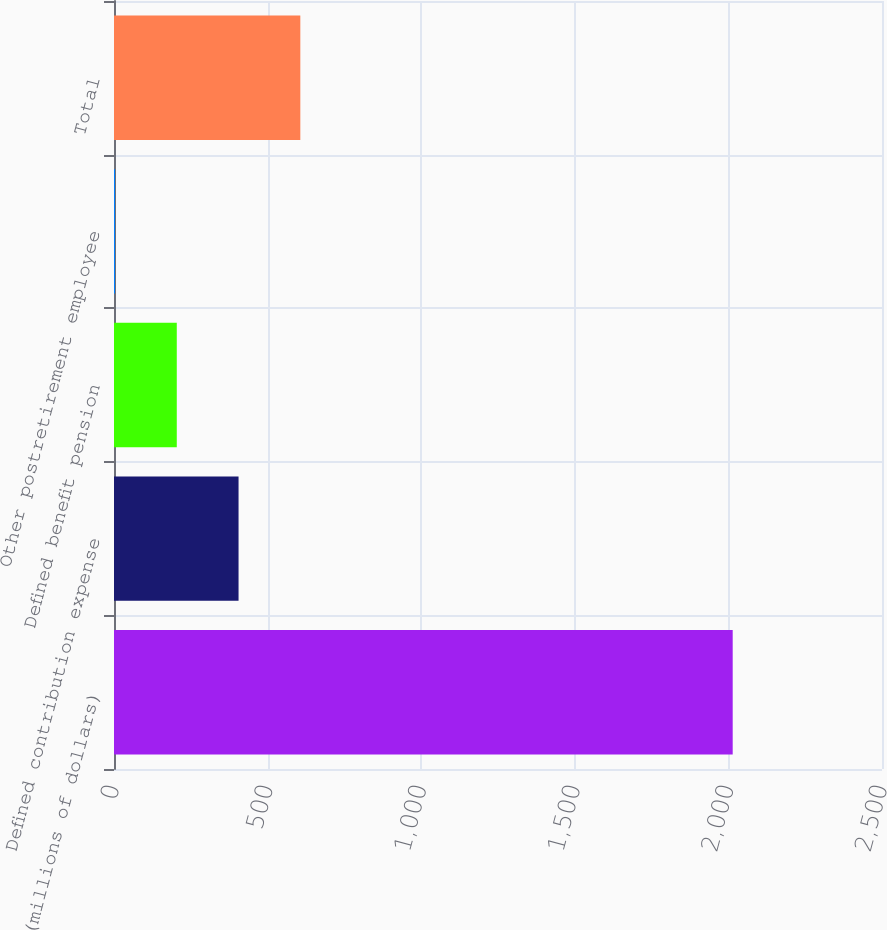<chart> <loc_0><loc_0><loc_500><loc_500><bar_chart><fcel>(millions of dollars)<fcel>Defined contribution expense<fcel>Defined benefit pension<fcel>Other postretirement employee<fcel>Total<nl><fcel>2014<fcel>405.44<fcel>204.37<fcel>3.3<fcel>606.51<nl></chart> 